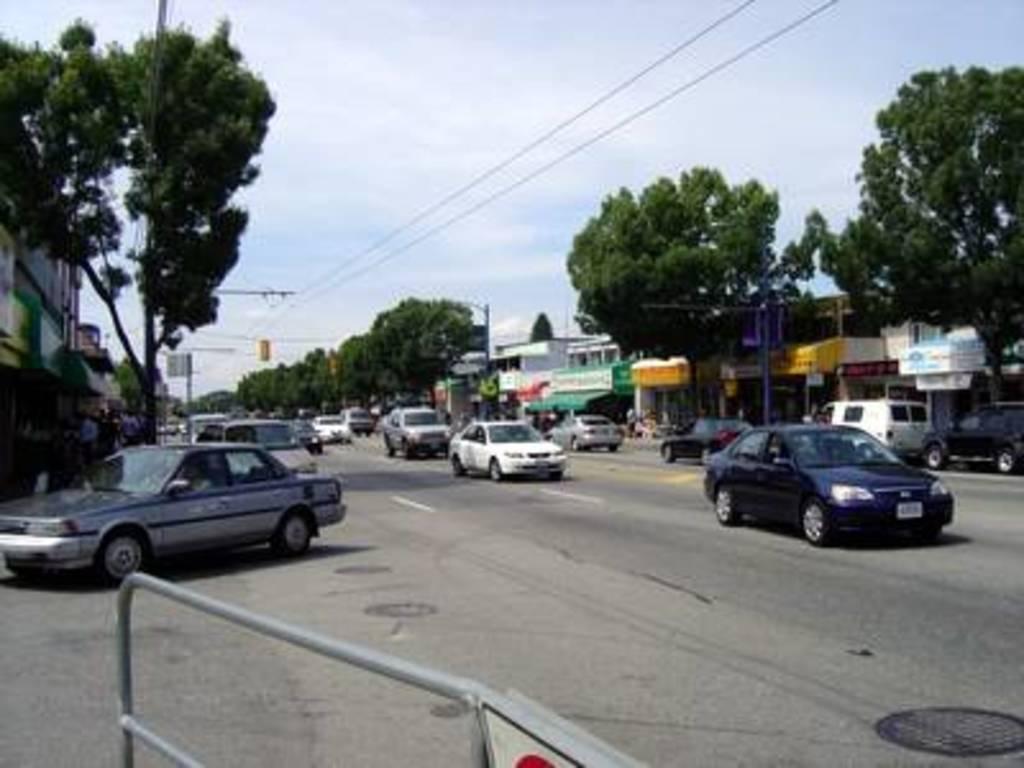In one or two sentences, can you explain what this image depicts? In this image, we can see a few vehicles. We can see the ground. We can see some trees. There are a few poles. We can see some wires. We can see some boards with text written. There are a few houses. We can see the sky. We can see the fence. 